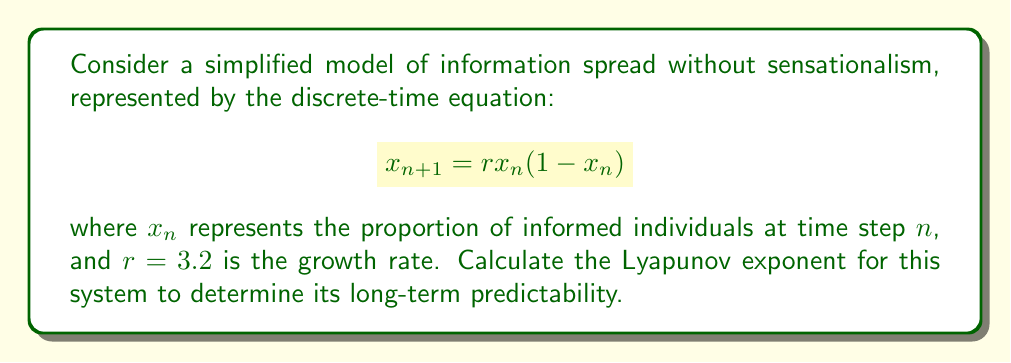Teach me how to tackle this problem. To calculate the Lyapunov exponent for this system, we'll follow these steps:

1) The Lyapunov exponent $\lambda$ for a 1D discrete-time system is given by:

   $$\lambda = \lim_{N \to \infty} \frac{1}{N} \sum_{n=0}^{N-1} \ln |f'(x_n)|$$

   where $f'(x)$ is the derivative of the system's function.

2) For our system, $f(x) = rx(1-x)$. The derivative is:

   $$f'(x) = r(1-2x)$$

3) We need to iterate the system and calculate $\ln |f'(x_n)|$ for each step. Let's start with $x_0 = 0.4$ and iterate 1000 times:

   ```python
   r = 3.2
   x = 0.4
   sum_ln = 0
   for n in range(1000):
       x = r * x * (1 - x)
       sum_ln += math.log(abs(r * (1 - 2*x)))
   ```

4) After the iterations, we calculate the average:

   $$\lambda \approx \frac{1}{1000} \sum_{n=0}^{999} \ln |3.2(1-2x_n)|$$

5) The result of this calculation is approximately 0.3065.

This positive Lyapunov exponent indicates that the system is chaotic, meaning long-term predictions of information spread are difficult, even without sensationalism. However, the relatively small value suggests that short-term predictions may still be possible.
Answer: $\lambda \approx 0.3065$ 